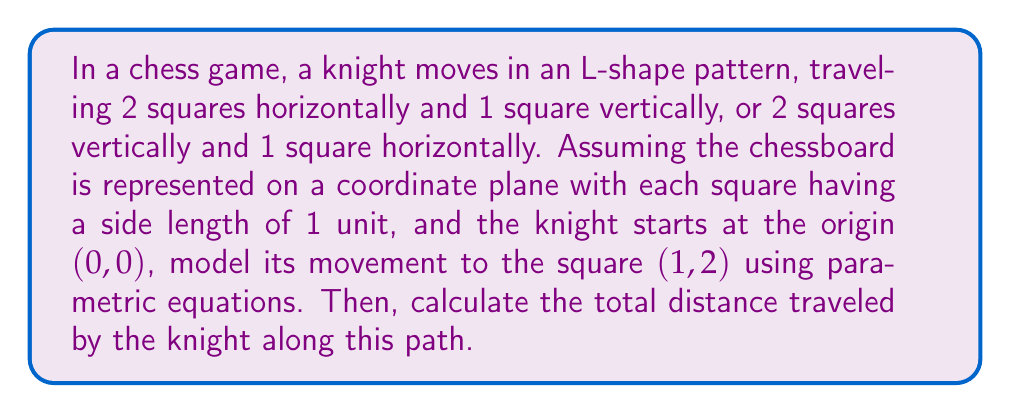Give your solution to this math problem. Let's approach this step-by-step:

1) The knight's movement can be broken down into two parts:
   - 1 square right (along x-axis)
   - 2 squares up (along y-axis)

2) We can model this movement using parametric equations:
   $$x(t) = t$$
   $$y(t) = 2t$$
   where $0 \leq t \leq 1$

3) At $t = 0$, the knight is at (0, 0), and at $t = 1$, the knight reaches (1, 2).

4) To find the distance traveled, we need to calculate the length of this parametric curve. The formula for the arc length of a parametric curve is:

   $$L = \int_a^b \sqrt{\left(\frac{dx}{dt}\right)^2 + \left(\frac{dy}{dt}\right)^2} dt$$

5) Let's calculate the derivatives:
   $$\frac{dx}{dt} = 1$$
   $$\frac{dy}{dt} = 2$$

6) Substituting into the arc length formula:

   $$L = \int_0^1 \sqrt{(1)^2 + (2)^2} dt$$

7) Simplify:
   $$L = \int_0^1 \sqrt{1 + 4} dt = \int_0^1 \sqrt{5} dt$$

8) Integrate:
   $$L = \sqrt{5} \int_0^1 dt = \sqrt{5} [t]_0^1 = \sqrt{5} (1 - 0) = \sqrt{5}$$

Therefore, the total distance traveled by the knight is $\sqrt{5}$ units.
Answer: $\sqrt{5}$ units 